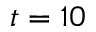<formula> <loc_0><loc_0><loc_500><loc_500>t = 1 0</formula> 